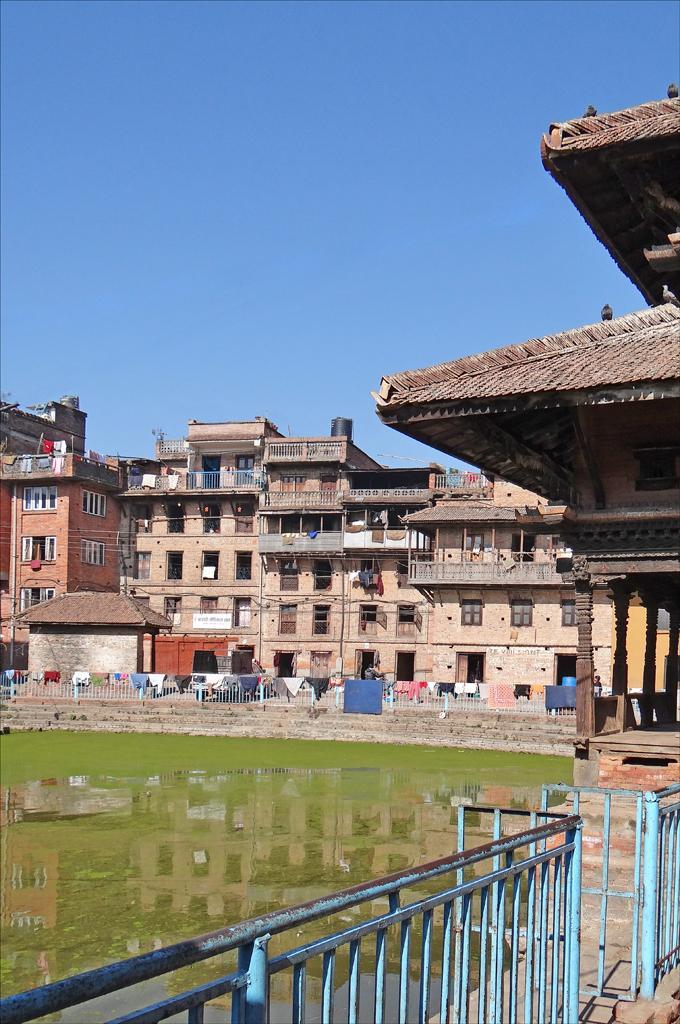Please provide a concise description of this image. In the picture we can see water around it, we can see the steps and house buildings with windows and we can also see a railing near the steps and in the background we can see a sky. 